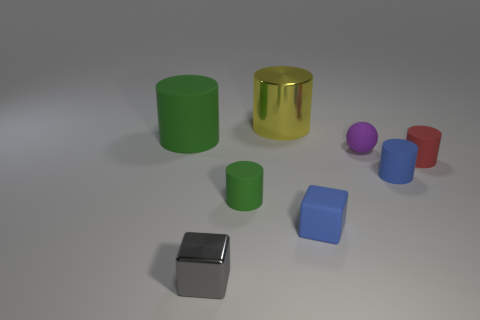There is a matte thing that is both to the right of the large yellow object and to the left of the small purple ball; what is its color?
Keep it short and to the point. Blue. Is the color of the small matte cylinder that is on the left side of the tiny purple rubber object the same as the large rubber cylinder?
Give a very brief answer. Yes. What is the shape of the metal thing that is the same size as the sphere?
Your answer should be very brief. Cube. What number of other things are there of the same color as the rubber cube?
Your answer should be compact. 1. What number of other things are the same material as the tiny green object?
Your answer should be compact. 5. Does the gray cube have the same size as the thing that is to the left of the tiny gray shiny cube?
Your answer should be very brief. No. The small matte sphere has what color?
Make the answer very short. Purple. There is a big rubber object that is in front of the metal thing right of the small matte cylinder on the left side of the yellow cylinder; what is its shape?
Your answer should be compact. Cylinder. What is the material of the green cylinder that is behind the tiny matte cylinder that is to the left of the blue cylinder?
Your response must be concise. Rubber. What shape is the big green object that is made of the same material as the red object?
Offer a very short reply. Cylinder. 